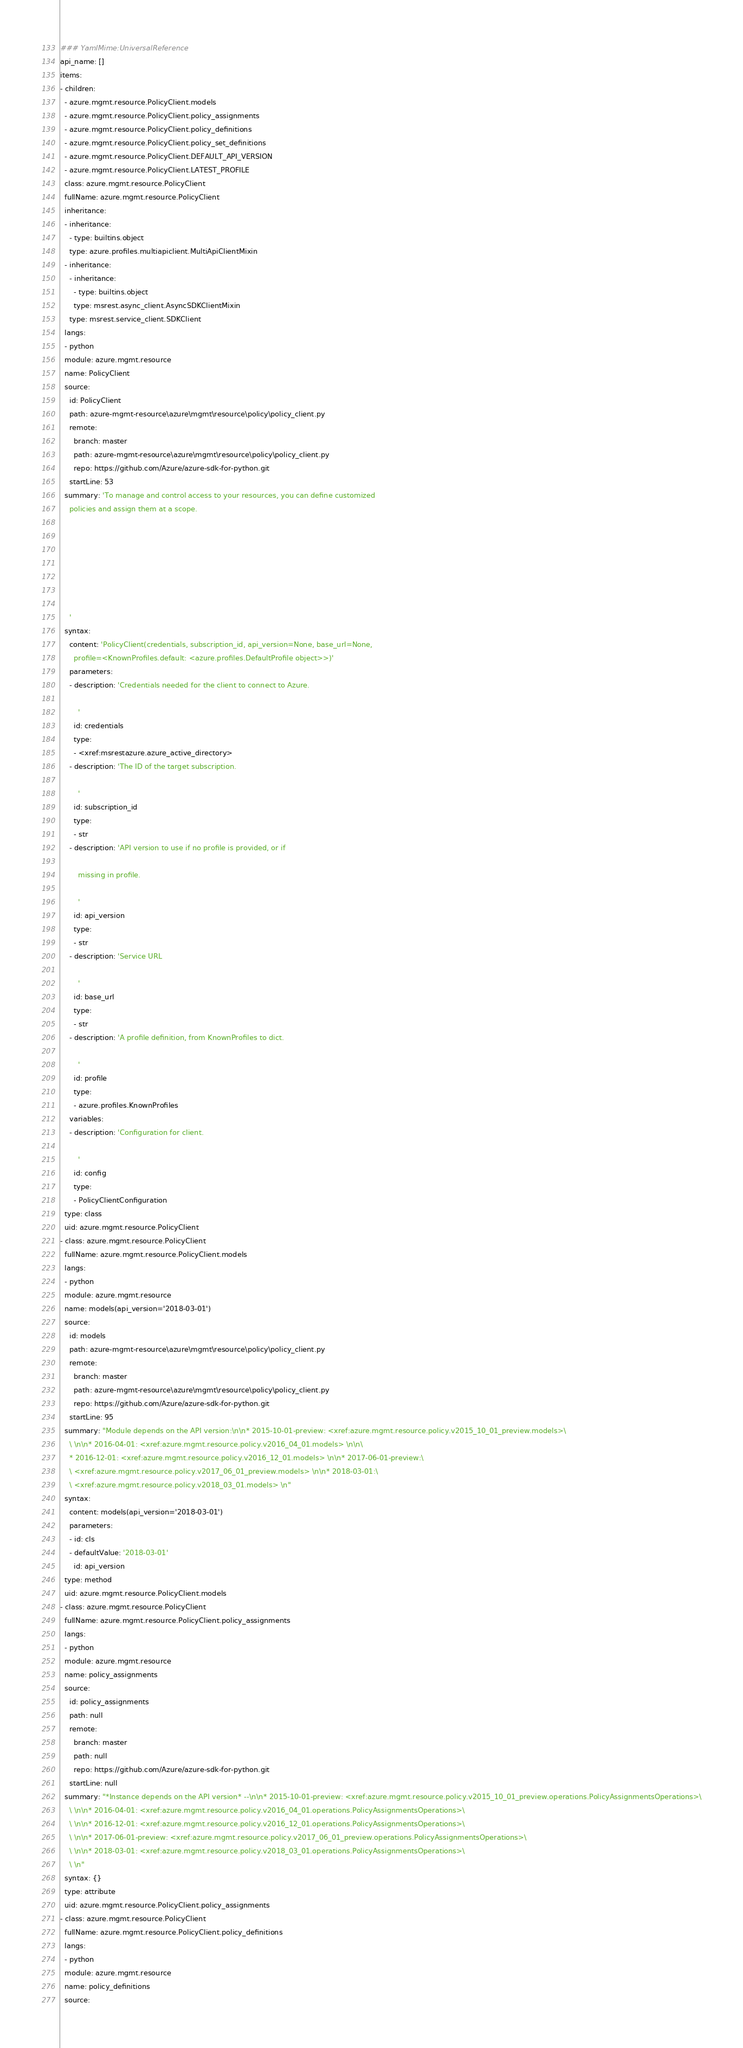Convert code to text. <code><loc_0><loc_0><loc_500><loc_500><_YAML_>### YamlMime:UniversalReference
api_name: []
items:
- children:
  - azure.mgmt.resource.PolicyClient.models
  - azure.mgmt.resource.PolicyClient.policy_assignments
  - azure.mgmt.resource.PolicyClient.policy_definitions
  - azure.mgmt.resource.PolicyClient.policy_set_definitions
  - azure.mgmt.resource.PolicyClient.DEFAULT_API_VERSION
  - azure.mgmt.resource.PolicyClient.LATEST_PROFILE
  class: azure.mgmt.resource.PolicyClient
  fullName: azure.mgmt.resource.PolicyClient
  inheritance:
  - inheritance:
    - type: builtins.object
    type: azure.profiles.multiapiclient.MultiApiClientMixin
  - inheritance:
    - inheritance:
      - type: builtins.object
      type: msrest.async_client.AsyncSDKClientMixin
    type: msrest.service_client.SDKClient
  langs:
  - python
  module: azure.mgmt.resource
  name: PolicyClient
  source:
    id: PolicyClient
    path: azure-mgmt-resource\azure\mgmt\resource\policy\policy_client.py
    remote:
      branch: master
      path: azure-mgmt-resource\azure\mgmt\resource\policy\policy_client.py
      repo: https://github.com/Azure/azure-sdk-for-python.git
    startLine: 53
  summary: 'To manage and control access to your resources, you can define customized
    policies and assign them at a scope.







    '
  syntax:
    content: 'PolicyClient(credentials, subscription_id, api_version=None, base_url=None,
      profile=<KnownProfiles.default: <azure.profiles.DefaultProfile object>>)'
    parameters:
    - description: 'Credentials needed for the client to connect to Azure.

        '
      id: credentials
      type:
      - <xref:msrestazure.azure_active_directory>
    - description: 'The ID of the target subscription.

        '
      id: subscription_id
      type:
      - str
    - description: 'API version to use if no profile is provided, or if

        missing in profile.

        '
      id: api_version
      type:
      - str
    - description: 'Service URL

        '
      id: base_url
      type:
      - str
    - description: 'A profile definition, from KnownProfiles to dict.

        '
      id: profile
      type:
      - azure.profiles.KnownProfiles
    variables:
    - description: 'Configuration for client.

        '
      id: config
      type:
      - PolicyClientConfiguration
  type: class
  uid: azure.mgmt.resource.PolicyClient
- class: azure.mgmt.resource.PolicyClient
  fullName: azure.mgmt.resource.PolicyClient.models
  langs:
  - python
  module: azure.mgmt.resource
  name: models(api_version='2018-03-01')
  source:
    id: models
    path: azure-mgmt-resource\azure\mgmt\resource\policy\policy_client.py
    remote:
      branch: master
      path: azure-mgmt-resource\azure\mgmt\resource\policy\policy_client.py
      repo: https://github.com/Azure/azure-sdk-for-python.git
    startLine: 95
  summary: "Module depends on the API version:\n\n* 2015-10-01-preview: <xref:azure.mgmt.resource.policy.v2015_10_01_preview.models>\
    \ \n\n* 2016-04-01: <xref:azure.mgmt.resource.policy.v2016_04_01.models> \n\n\
    * 2016-12-01: <xref:azure.mgmt.resource.policy.v2016_12_01.models> \n\n* 2017-06-01-preview:\
    \ <xref:azure.mgmt.resource.policy.v2017_06_01_preview.models> \n\n* 2018-03-01:\
    \ <xref:azure.mgmt.resource.policy.v2018_03_01.models> \n"
  syntax:
    content: models(api_version='2018-03-01')
    parameters:
    - id: cls
    - defaultValue: '2018-03-01'
      id: api_version
  type: method
  uid: azure.mgmt.resource.PolicyClient.models
- class: azure.mgmt.resource.PolicyClient
  fullName: azure.mgmt.resource.PolicyClient.policy_assignments
  langs:
  - python
  module: azure.mgmt.resource
  name: policy_assignments
  source:
    id: policy_assignments
    path: null
    remote:
      branch: master
      path: null
      repo: https://github.com/Azure/azure-sdk-for-python.git
    startLine: null
  summary: "*Instance depends on the API version* --\n\n* 2015-10-01-preview: <xref:azure.mgmt.resource.policy.v2015_10_01_preview.operations.PolicyAssignmentsOperations>\
    \ \n\n* 2016-04-01: <xref:azure.mgmt.resource.policy.v2016_04_01.operations.PolicyAssignmentsOperations>\
    \ \n\n* 2016-12-01: <xref:azure.mgmt.resource.policy.v2016_12_01.operations.PolicyAssignmentsOperations>\
    \ \n\n* 2017-06-01-preview: <xref:azure.mgmt.resource.policy.v2017_06_01_preview.operations.PolicyAssignmentsOperations>\
    \ \n\n* 2018-03-01: <xref:azure.mgmt.resource.policy.v2018_03_01.operations.PolicyAssignmentsOperations>\
    \ \n"
  syntax: {}
  type: attribute
  uid: azure.mgmt.resource.PolicyClient.policy_assignments
- class: azure.mgmt.resource.PolicyClient
  fullName: azure.mgmt.resource.PolicyClient.policy_definitions
  langs:
  - python
  module: azure.mgmt.resource
  name: policy_definitions
  source:</code> 